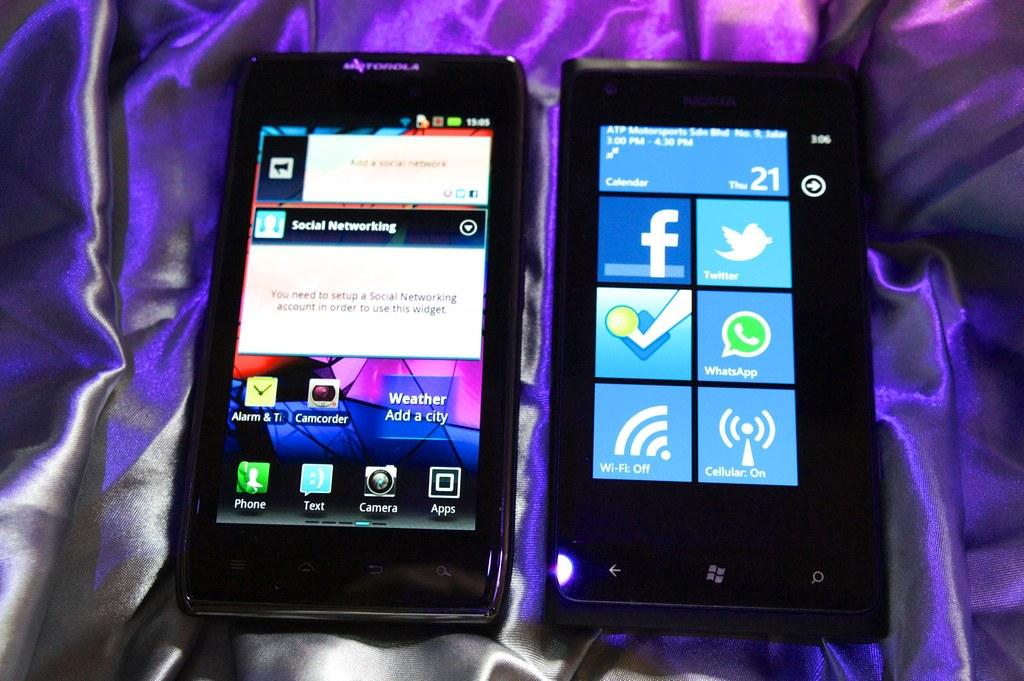Is the right phone's wifi on or off?
Provide a short and direct response. Off. What is the number on the top right of the second phone?
Ensure brevity in your answer.  21. 